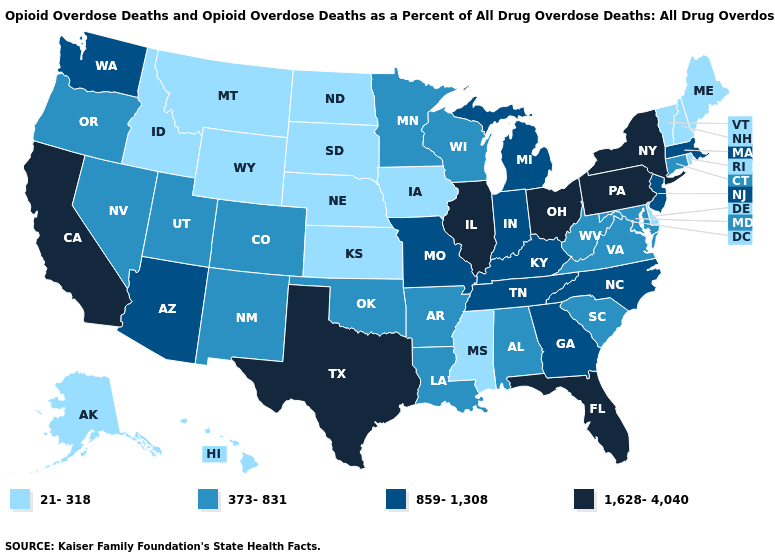Which states have the lowest value in the Northeast?
Short answer required. Maine, New Hampshire, Rhode Island, Vermont. What is the value of Nebraska?
Answer briefly. 21-318. What is the value of Washington?
Quick response, please. 859-1,308. What is the value of Oregon?
Be succinct. 373-831. Name the states that have a value in the range 373-831?
Short answer required. Alabama, Arkansas, Colorado, Connecticut, Louisiana, Maryland, Minnesota, Nevada, New Mexico, Oklahoma, Oregon, South Carolina, Utah, Virginia, West Virginia, Wisconsin. Does the map have missing data?
Concise answer only. No. What is the value of Washington?
Write a very short answer. 859-1,308. What is the highest value in the West ?
Keep it brief. 1,628-4,040. What is the lowest value in the USA?
Short answer required. 21-318. What is the value of New Jersey?
Quick response, please. 859-1,308. What is the lowest value in the South?
Concise answer only. 21-318. Does New Mexico have a lower value than Nevada?
Write a very short answer. No. What is the highest value in the MidWest ?
Write a very short answer. 1,628-4,040. Does New Mexico have a lower value than Rhode Island?
Concise answer only. No. What is the value of North Dakota?
Keep it brief. 21-318. 